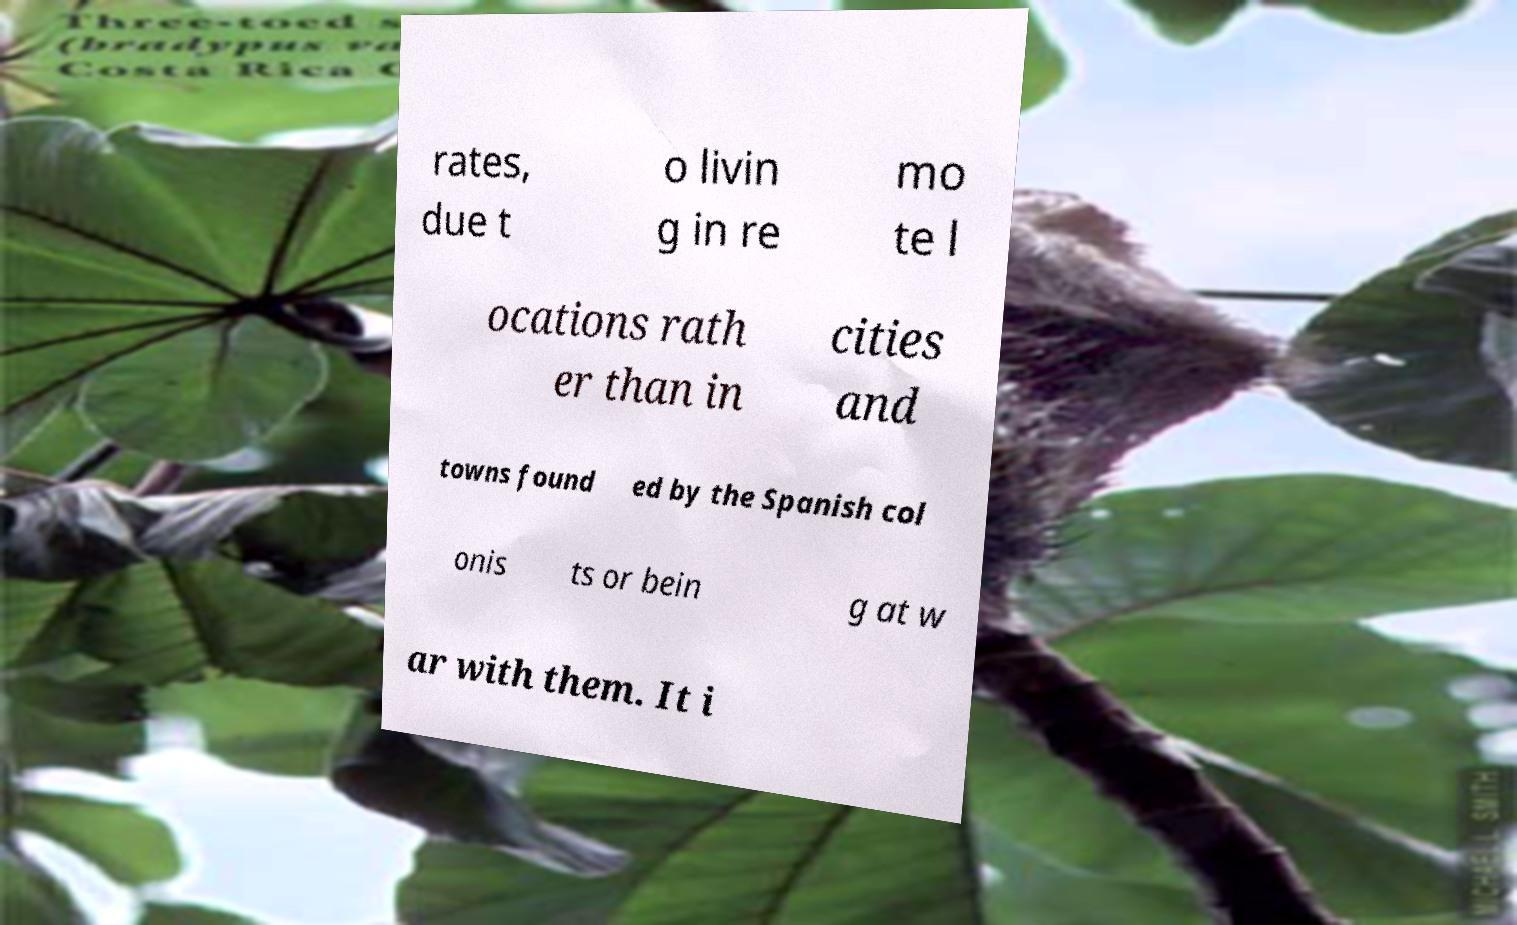Could you assist in decoding the text presented in this image and type it out clearly? rates, due t o livin g in re mo te l ocations rath er than in cities and towns found ed by the Spanish col onis ts or bein g at w ar with them. It i 